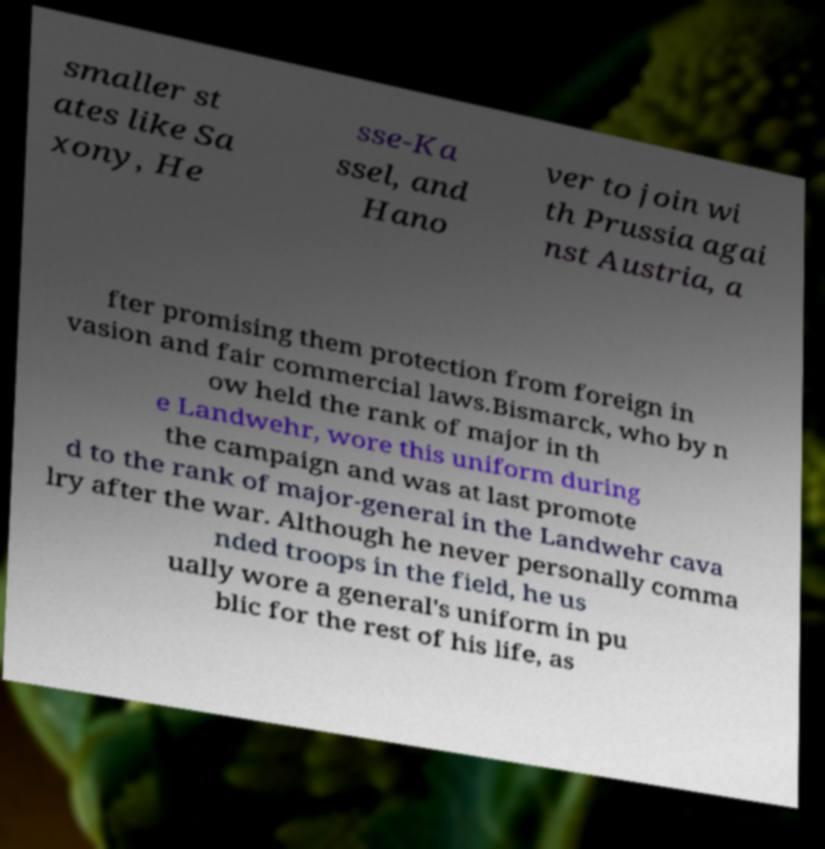Please read and relay the text visible in this image. What does it say? smaller st ates like Sa xony, He sse-Ka ssel, and Hano ver to join wi th Prussia agai nst Austria, a fter promising them protection from foreign in vasion and fair commercial laws.Bismarck, who by n ow held the rank of major in th e Landwehr, wore this uniform during the campaign and was at last promote d to the rank of major-general in the Landwehr cava lry after the war. Although he never personally comma nded troops in the field, he us ually wore a general's uniform in pu blic for the rest of his life, as 